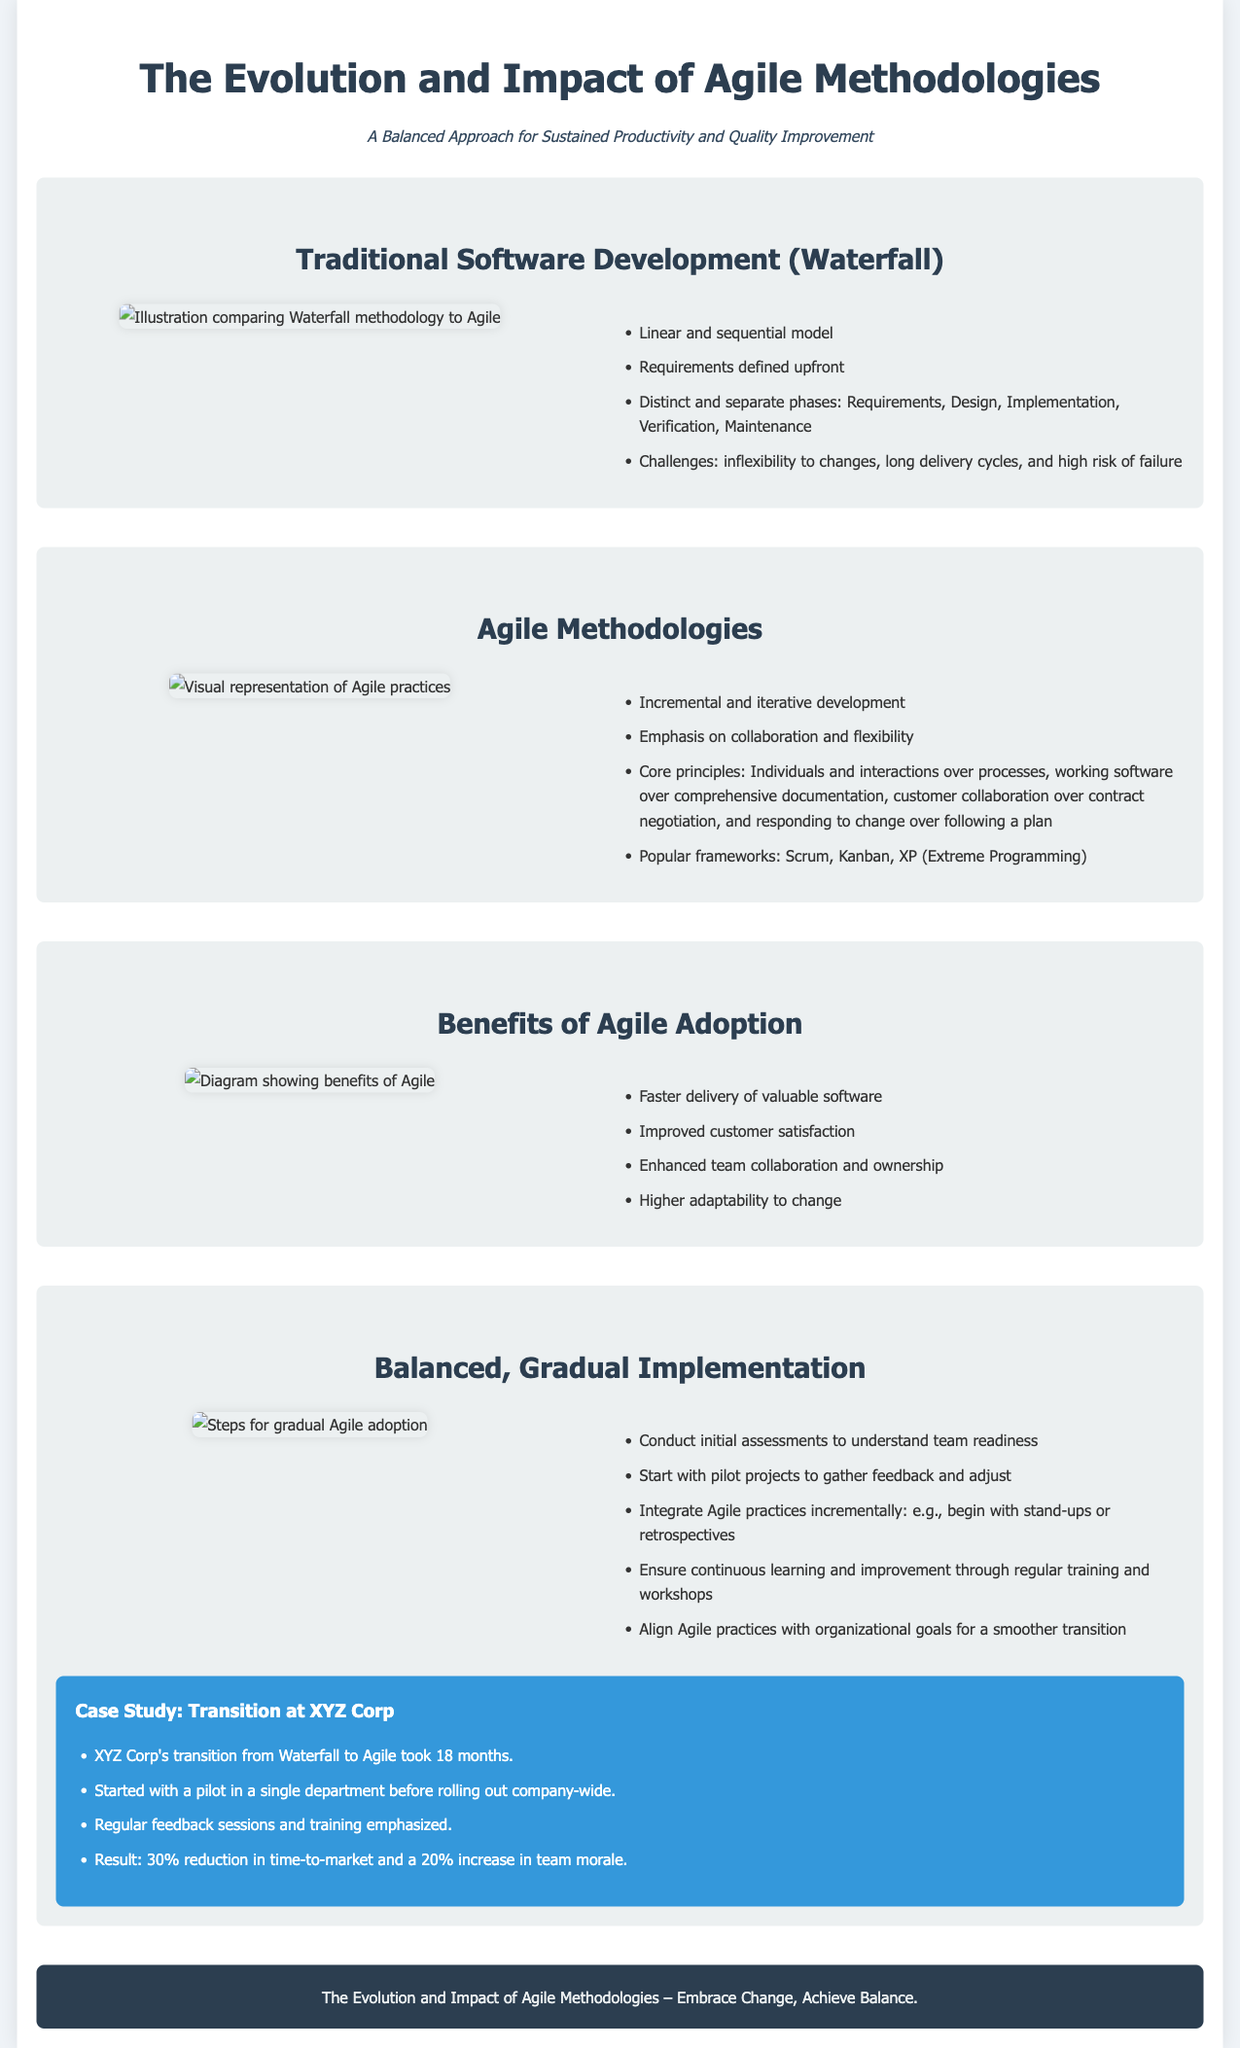What is the title of the document? The title is presented at the top of the document.
Answer: The Evolution and Impact of Agile Methodologies What methodology is characterized by linear and sequential processes? This information is found in the section about Traditional Software Development.
Answer: Waterfall What are the four core principles of Agile? The four principles are listed in the section on Agile Methodologies.
Answer: Individuals and interactions, working software, customer collaboration, responding to change What is the benefit of Agile in terms of delivery speed? This is mentioned in the Benefits of Agile Adoption section.
Answer: Faster delivery of valuable software How long did XYZ Corp's transition to Agile take? This information is found in the case study about XYZ Corp.
Answer: 18 months What practice is suggested as a starting point for Agile implementation? This is detailed in the Balanced, Gradual Implementation section.
Answer: Stand-ups What method is used to depict the benefits of Agile? This description pertains to the visual content in the document.
Answer: Diagram How much did XYZ Corp reduce their time-to-market? This information is part of the case study regarding XYZ Corp's transition.
Answer: 30% 